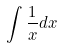Convert formula to latex. <formula><loc_0><loc_0><loc_500><loc_500>\int \frac { 1 } { x } d x</formula> 